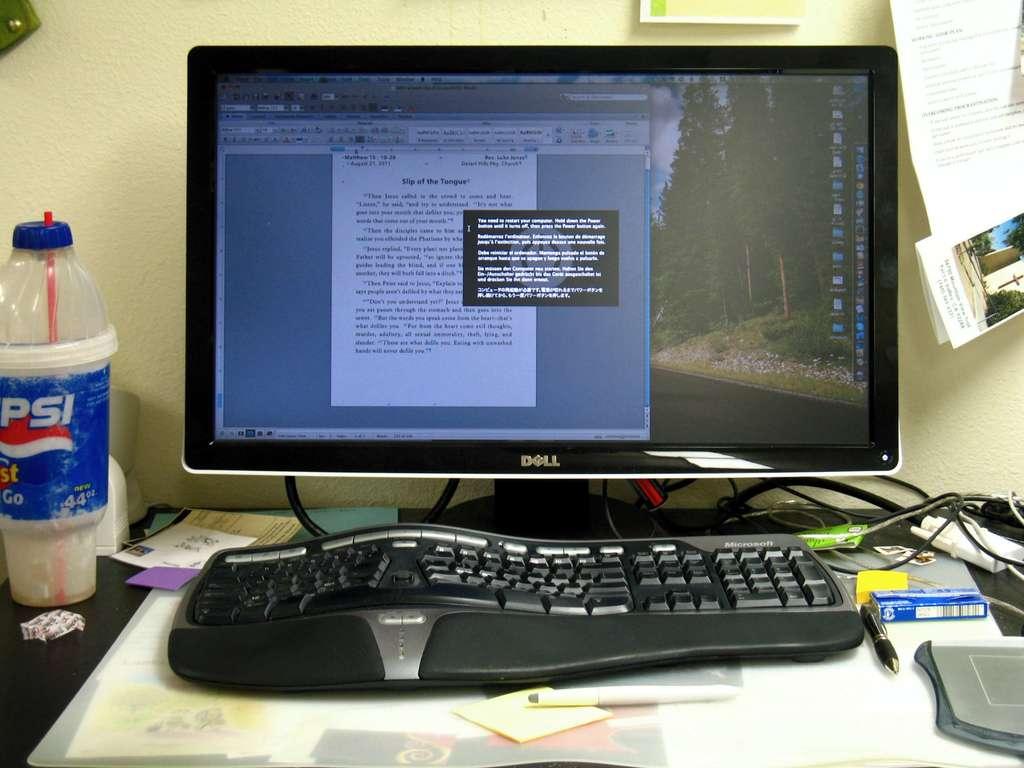What drink is on the desk?
Offer a terse response. Pepsi. What company makes the monitor?
Give a very brief answer. Dell. 